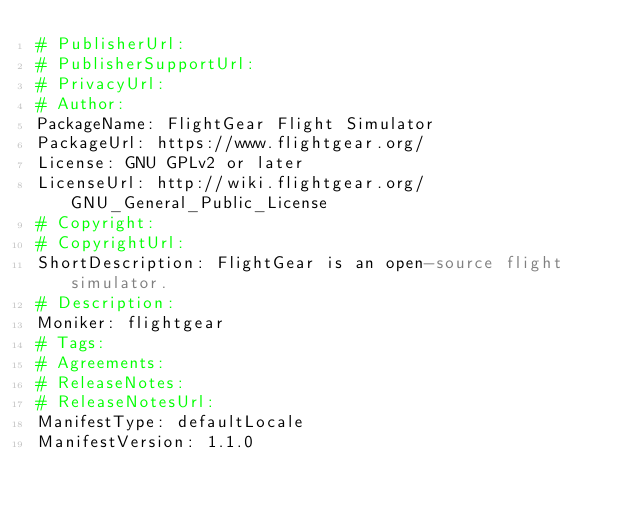<code> <loc_0><loc_0><loc_500><loc_500><_YAML_># PublisherUrl: 
# PublisherSupportUrl: 
# PrivacyUrl: 
# Author: 
PackageName: FlightGear Flight Simulator
PackageUrl: https://www.flightgear.org/
License: GNU GPLv2 or later
LicenseUrl: http://wiki.flightgear.org/GNU_General_Public_License
# Copyright: 
# CopyrightUrl: 
ShortDescription: FlightGear is an open-source flight simulator.
# Description: 
Moniker: flightgear
# Tags: 
# Agreements: 
# ReleaseNotes: 
# ReleaseNotesUrl: 
ManifestType: defaultLocale
ManifestVersion: 1.1.0
</code> 